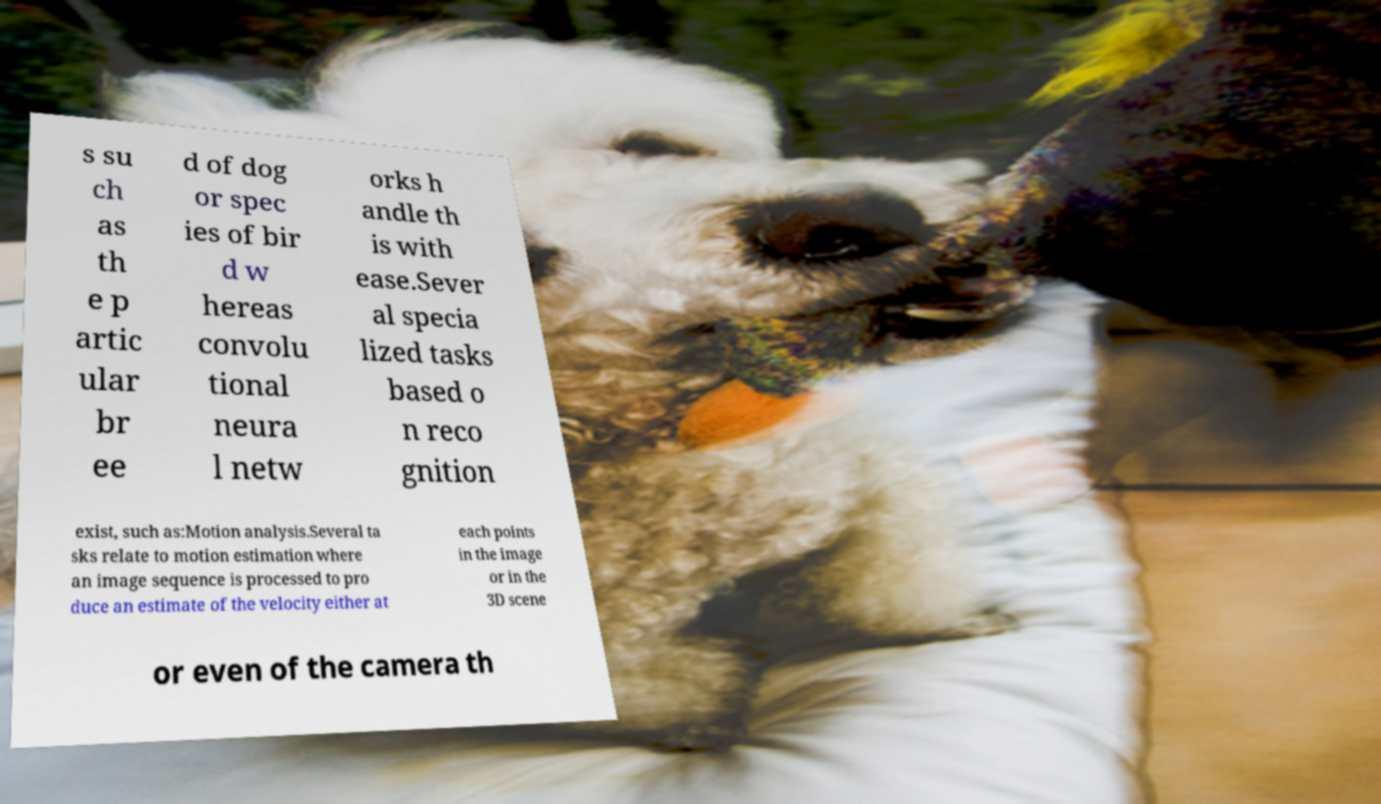There's text embedded in this image that I need extracted. Can you transcribe it verbatim? s su ch as th e p artic ular br ee d of dog or spec ies of bir d w hereas convolu tional neura l netw orks h andle th is with ease.Sever al specia lized tasks based o n reco gnition exist, such as:Motion analysis.Several ta sks relate to motion estimation where an image sequence is processed to pro duce an estimate of the velocity either at each points in the image or in the 3D scene or even of the camera th 